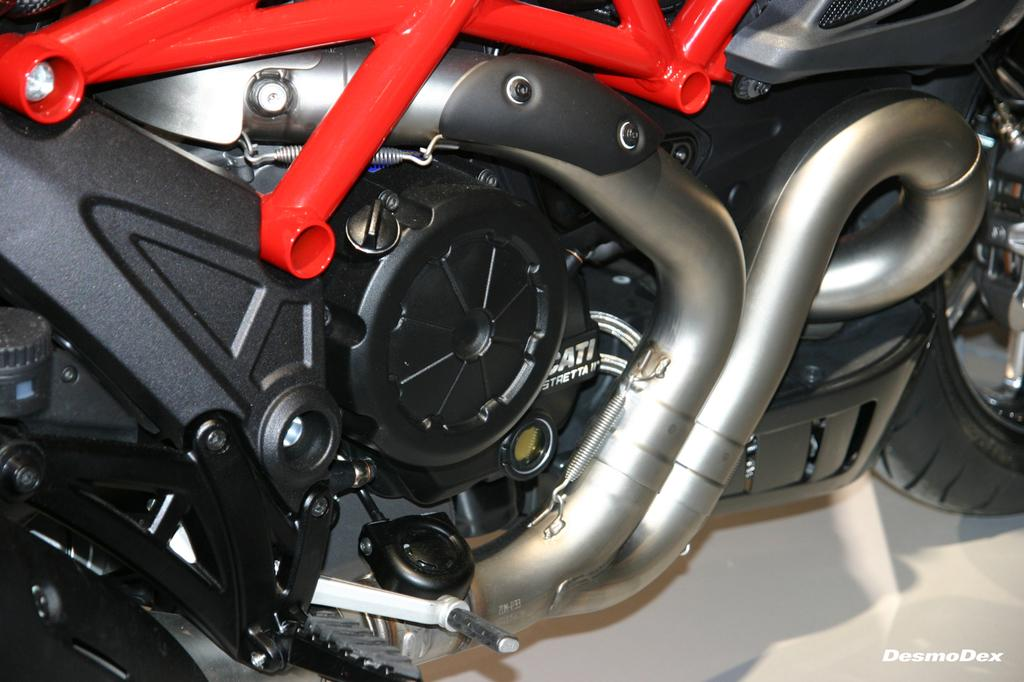What is the main subject in the foreground of the image? There is a truncated motorbike in the foreground of the image. What is the color of the surface the motorbike is on? The motorbike is on a white surface. What specific parts of the motorbike can be seen in the image? The kick rod, pedal, and tyre are visible on the motorbike, along with other parts. What type of lace is being used to repair the motorbike in the image? There is no lace present in the image, and the motorbike is not being repaired. Is the motorbike's father present in the image? There is no reference to a motorbike's father in the image, and the concept of a motorbike having a father is not applicable. 